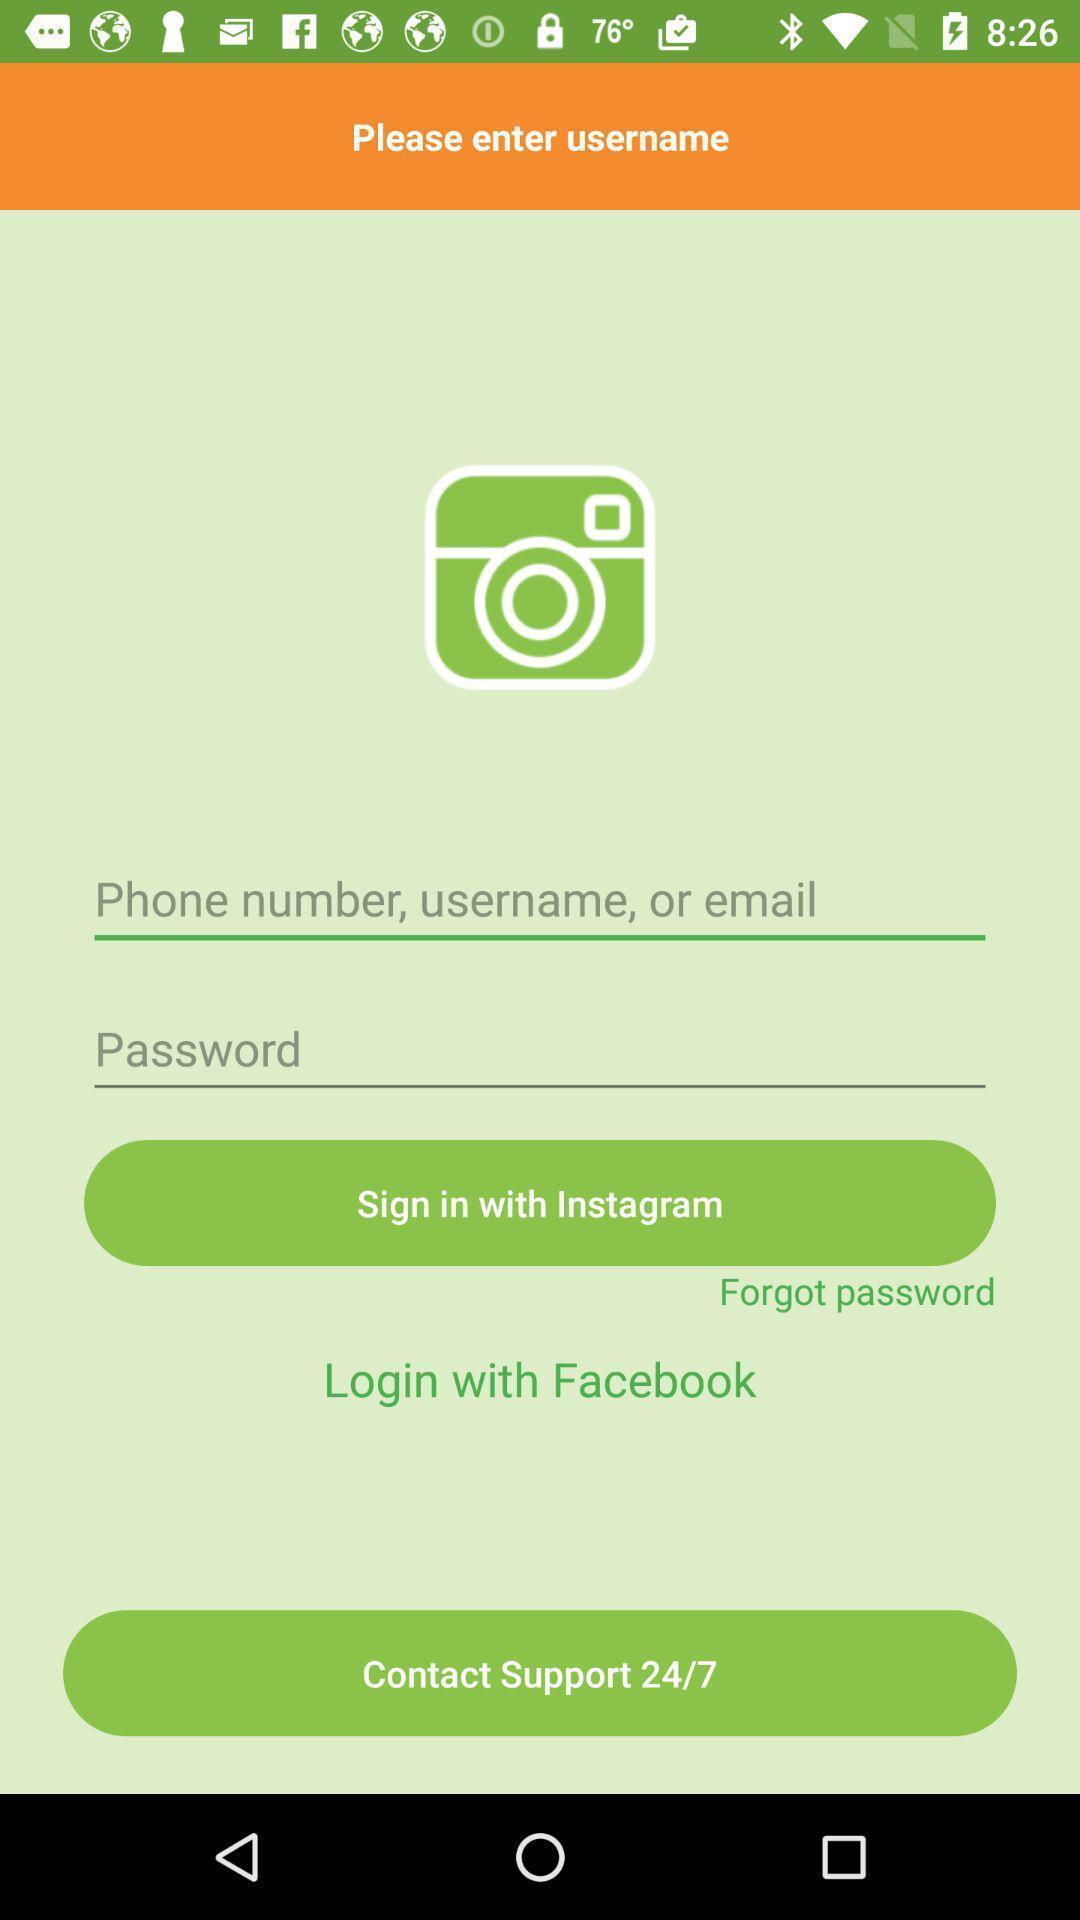Give me a narrative description of this picture. Sign in page. 